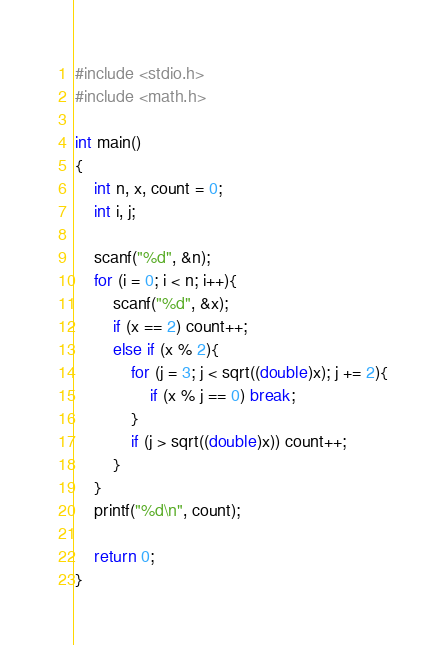<code> <loc_0><loc_0><loc_500><loc_500><_C++_>
#include <stdio.h>
#include <math.h>

int main()
{
    int n, x, count = 0;
    int i, j;
    
    scanf("%d", &n);
    for (i = 0; i < n; i++){
        scanf("%d", &x);
        if (x == 2) count++;
        else if (x % 2){
            for (j = 3; j < sqrt((double)x); j += 2){
                if (x % j == 0) break;
            }
            if (j > sqrt((double)x)) count++;
        }
    }
    printf("%d\n", count);
    
    return 0;
}</code> 